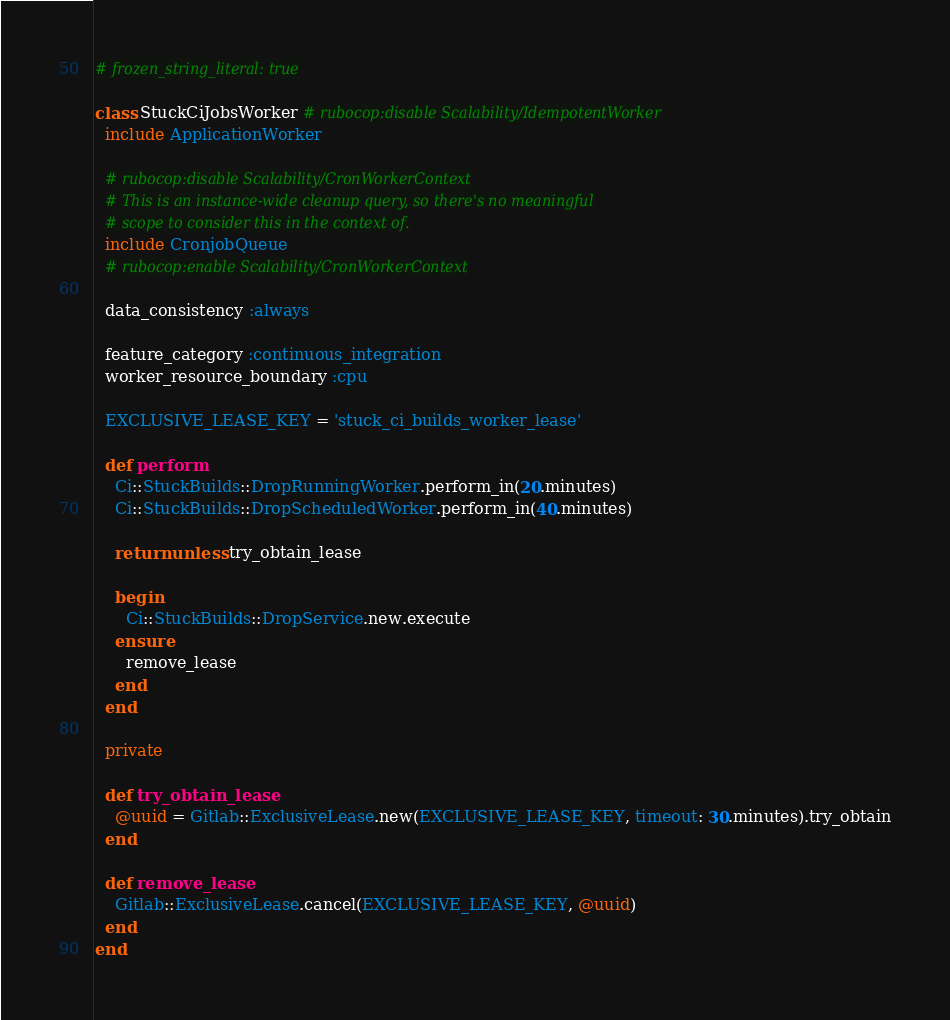<code> <loc_0><loc_0><loc_500><loc_500><_Ruby_># frozen_string_literal: true

class StuckCiJobsWorker # rubocop:disable Scalability/IdempotentWorker
  include ApplicationWorker

  # rubocop:disable Scalability/CronWorkerContext
  # This is an instance-wide cleanup query, so there's no meaningful
  # scope to consider this in the context of.
  include CronjobQueue
  # rubocop:enable Scalability/CronWorkerContext

  data_consistency :always

  feature_category :continuous_integration
  worker_resource_boundary :cpu

  EXCLUSIVE_LEASE_KEY = 'stuck_ci_builds_worker_lease'

  def perform
    Ci::StuckBuilds::DropRunningWorker.perform_in(20.minutes)
    Ci::StuckBuilds::DropScheduledWorker.perform_in(40.minutes)

    return unless try_obtain_lease

    begin
      Ci::StuckBuilds::DropService.new.execute
    ensure
      remove_lease
    end
  end

  private

  def try_obtain_lease
    @uuid = Gitlab::ExclusiveLease.new(EXCLUSIVE_LEASE_KEY, timeout: 30.minutes).try_obtain
  end

  def remove_lease
    Gitlab::ExclusiveLease.cancel(EXCLUSIVE_LEASE_KEY, @uuid)
  end
end
</code> 